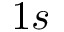<formula> <loc_0><loc_0><loc_500><loc_500>1 s</formula> 